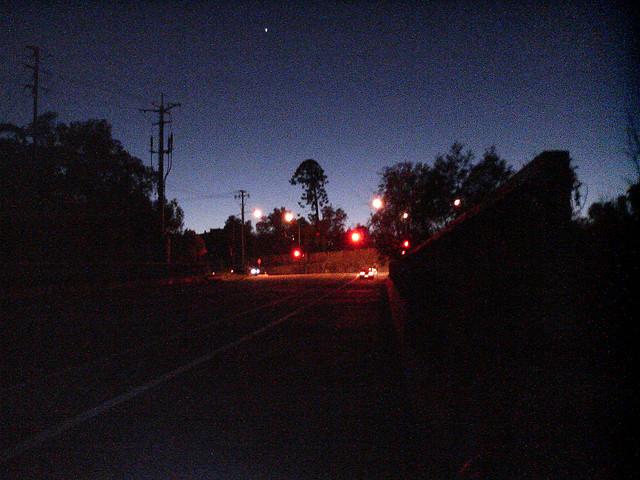What time of day is it?
Short answer required. Night. Is the sky clear?
Quick response, please. Yes. How many lights are shown?
Give a very brief answer. 8. What two traffic signs are present?
Write a very short answer. Stop lights. What is there a silhouette of?
Quick response, please. Street. How many trucks are there?
Short answer required. 0. How many plants are in the scene?
Give a very brief answer. 5. Is this a city?
Answer briefly. No. What color is the traffic light?
Keep it brief. Red. 